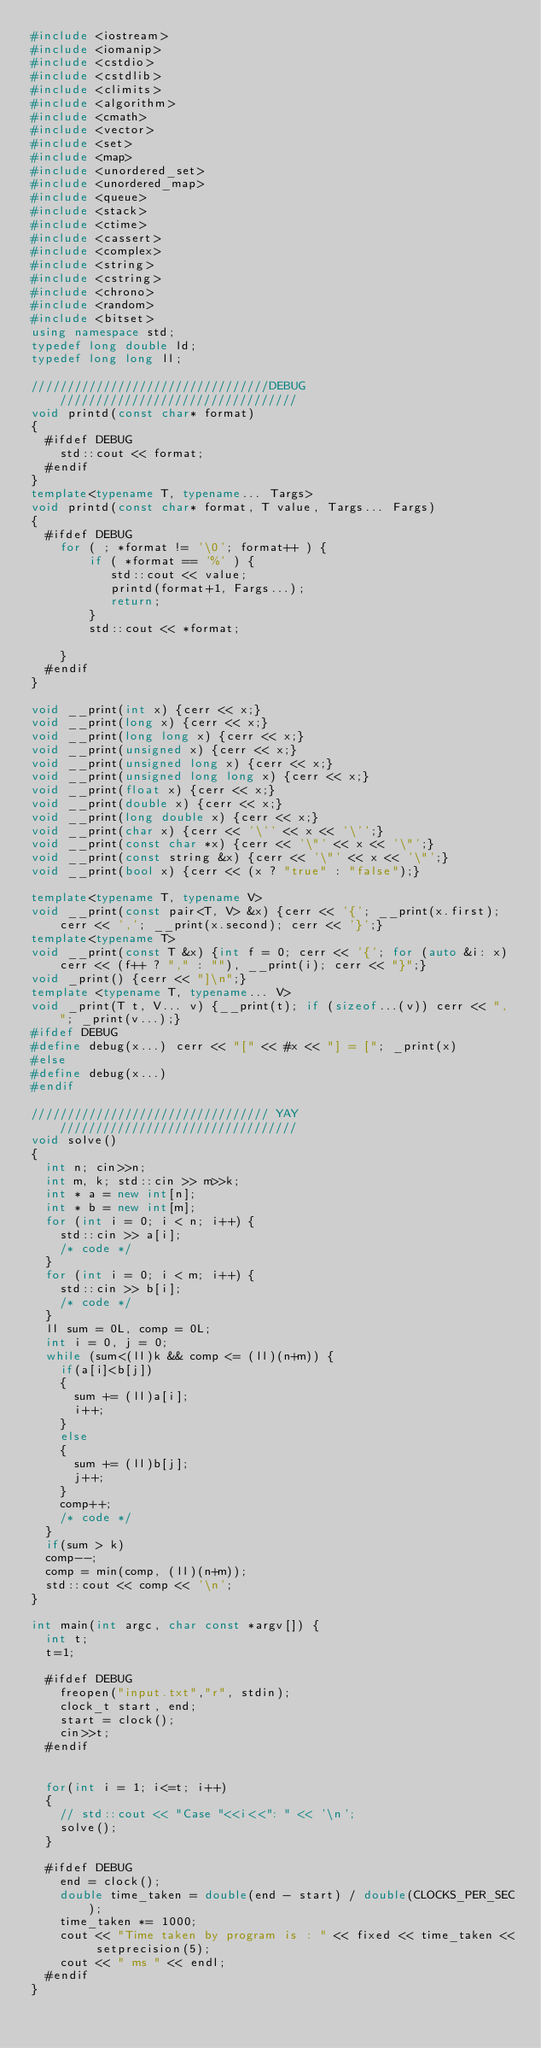<code> <loc_0><loc_0><loc_500><loc_500><_C++_>#include <iostream>
#include <iomanip>
#include <cstdio>
#include <cstdlib>
#include <climits>
#include <algorithm>
#include <cmath>
#include <vector>
#include <set>
#include <map>
#include <unordered_set>
#include <unordered_map>
#include <queue>
#include <stack>
#include <ctime>
#include <cassert>
#include <complex>
#include <string>
#include <cstring>
#include <chrono>
#include <random>
#include <bitset>
using namespace std;
typedef long double ld;
typedef long long ll;

/////////////////////////////////DEBUG/////////////////////////////////
void printd(const char* format)
{
  #ifdef DEBUG
    std::cout << format;
  #endif
}
template<typename T, typename... Targs>
void printd(const char* format, T value, Targs... Fargs)
{
  #ifdef DEBUG
    for ( ; *format != '\0'; format++ ) {
        if ( *format == '%' ) {
           std::cout << value;
           printd(format+1, Fargs...);
           return;
        }
        std::cout << *format;

    }
  #endif
}

void __print(int x) {cerr << x;}
void __print(long x) {cerr << x;}
void __print(long long x) {cerr << x;}
void __print(unsigned x) {cerr << x;}
void __print(unsigned long x) {cerr << x;}
void __print(unsigned long long x) {cerr << x;}
void __print(float x) {cerr << x;}
void __print(double x) {cerr << x;}
void __print(long double x) {cerr << x;}
void __print(char x) {cerr << '\'' << x << '\'';}
void __print(const char *x) {cerr << '\"' << x << '\"';}
void __print(const string &x) {cerr << '\"' << x << '\"';}
void __print(bool x) {cerr << (x ? "true" : "false");}

template<typename T, typename V>
void __print(const pair<T, V> &x) {cerr << '{'; __print(x.first); cerr << ','; __print(x.second); cerr << '}';}
template<typename T>
void __print(const T &x) {int f = 0; cerr << '{'; for (auto &i: x) cerr << (f++ ? "," : ""), __print(i); cerr << "}";}
void _print() {cerr << "]\n";}
template <typename T, typename... V>
void _print(T t, V... v) {__print(t); if (sizeof...(v)) cerr << ", "; _print(v...);}
#ifdef DEBUG
#define debug(x...) cerr << "[" << #x << "] = ["; _print(x)
#else
#define debug(x...)
#endif

///////////////////////////////// YAY /////////////////////////////////
void solve()
{
  int n; cin>>n;
  int m, k; std::cin >> m>>k;
  int * a = new int[n];
  int * b = new int[m];
  for (int i = 0; i < n; i++) {
    std::cin >> a[i];
    /* code */
  }
  for (int i = 0; i < m; i++) {
    std::cin >> b[i];
    /* code */
  }
  ll sum = 0L, comp = 0L;
  int i = 0, j = 0;
  while (sum<(ll)k && comp <= (ll)(n+m)) {
    if(a[i]<b[j])
    {
      sum += (ll)a[i];
      i++;
    }
    else
    {
      sum += (ll)b[j];
      j++;
    }
    comp++;
    /* code */
  }
  if(sum > k)
  comp--;
  comp = min(comp, (ll)(n+m));
  std::cout << comp << '\n';
}

int main(int argc, char const *argv[]) {
  int t;
  t=1;

  #ifdef DEBUG
    freopen("input.txt","r", stdin);
    clock_t start, end;
    start = clock();
    cin>>t;
  #endif


  for(int i = 1; i<=t; i++)
  {
    // std::cout << "Case "<<i<<": " << '\n';
    solve();
  }

  #ifdef DEBUG
    end = clock();
    double time_taken = double(end - start) / double(CLOCKS_PER_SEC);
    time_taken *= 1000;
    cout << "Time taken by program is : " << fixed << time_taken << setprecision(5);
    cout << " ms " << endl;
  #endif
}
</code> 